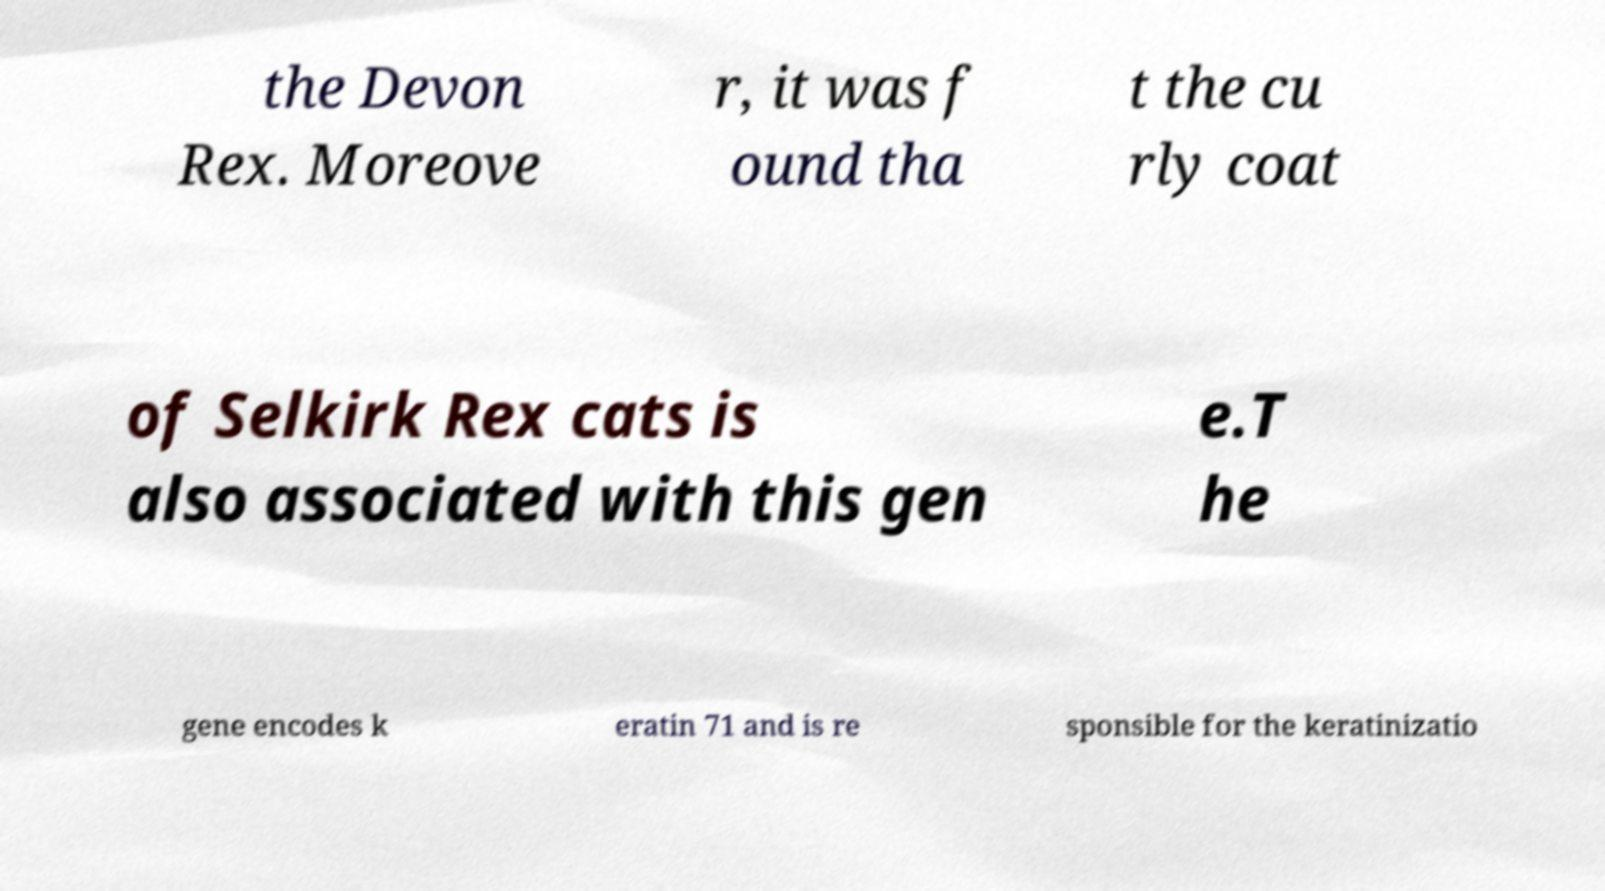What messages or text are displayed in this image? I need them in a readable, typed format. the Devon Rex. Moreove r, it was f ound tha t the cu rly coat of Selkirk Rex cats is also associated with this gen e.T he gene encodes k eratin 71 and is re sponsible for the keratinizatio 